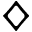<formula> <loc_0><loc_0><loc_500><loc_500>\diamondsuit</formula> 